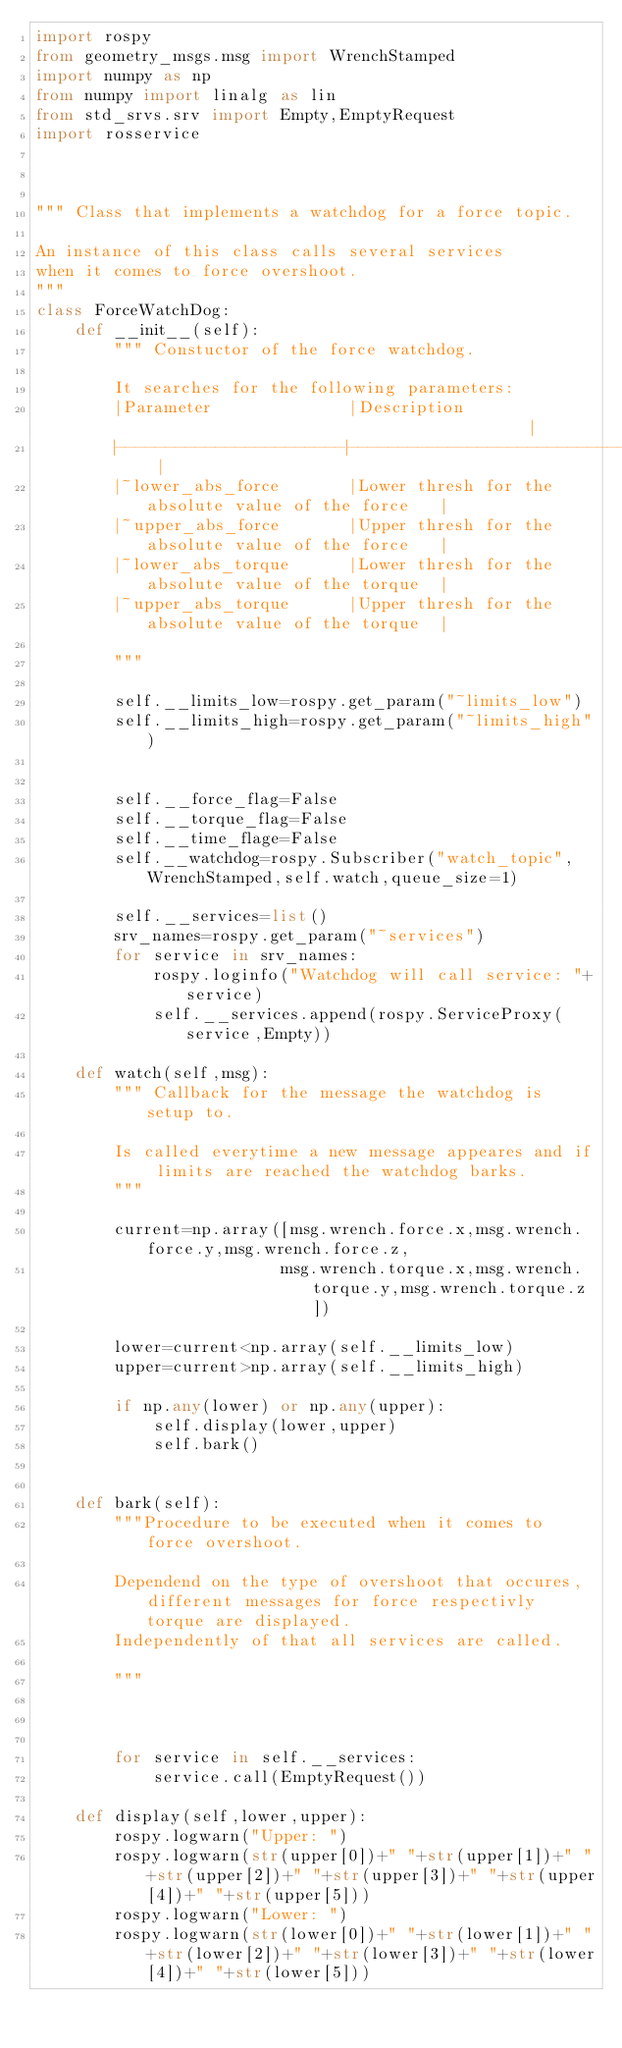<code> <loc_0><loc_0><loc_500><loc_500><_Python_>import rospy
from geometry_msgs.msg import WrenchStamped
import numpy as np
from numpy import linalg as lin
from std_srvs.srv import Empty,EmptyRequest
import rosservice



""" Class that implements a watchdog for a force topic.

An instance of this class calls several services 
when it comes to force overshoot.
"""
class ForceWatchDog:
    def __init__(self): 
        """ Constuctor of the force watchdog.
        
        It searches for the following parameters:
        |Parameter              |Description                                        |
        |-----------------------|-------------------------------------------------- |
        |~lower_abs_force       |Lower thresh for the absolute value of the force   |
        |~upper_abs_force       |Upper thresh for the absolute value of the force   |
        |~lower_abs_torque      |Lower thresh for the absolute value of the torque  |
        |~upper_abs_torque      |Upper thresh for the absolute value of the torque  |
        
        """     

        self.__limits_low=rospy.get_param("~limits_low")
        self.__limits_high=rospy.get_param("~limits_high")
       
       
        self.__force_flag=False
        self.__torque_flag=False
        self.__time_flage=False        
        self.__watchdog=rospy.Subscriber("watch_topic",WrenchStamped,self.watch,queue_size=1)
        
        self.__services=list()
        srv_names=rospy.get_param("~services")
        for service in srv_names:
            rospy.loginfo("Watchdog will call service: "+service)
            self.__services.append(rospy.ServiceProxy(service,Empty))

    def watch(self,msg):
        """ Callback for the message the watchdog is setup to.
        
        Is called everytime a new message appeares and if limits are reached the watchdog barks.
        """

        current=np.array([msg.wrench.force.x,msg.wrench.force.y,msg.wrench.force.z,
                         msg.wrench.torque.x,msg.wrench.torque.y,msg.wrench.torque.z])

        lower=current<np.array(self.__limits_low)
        upper=current>np.array(self.__limits_high)

        if np.any(lower) or np.any(upper):
            self.display(lower,upper)
            self.bark()
            

    def bark(self):
        """Procedure to be executed when it comes to force overshoot.

        Dependend on the type of overshoot that occures, different messages for force respectivly torque are displayed.
        Independently of that all services are called.

        """        
   
       
        
        for service in self.__services:
            service.call(EmptyRequest())
    
    def display(self,lower,upper):
        rospy.logwarn("Upper: ")
        rospy.logwarn(str(upper[0])+" "+str(upper[1])+" "+str(upper[2])+" "+str(upper[3])+" "+str(upper[4])+" "+str(upper[5]))
        rospy.logwarn("Lower: ")
        rospy.logwarn(str(lower[0])+" "+str(lower[1])+" "+str(lower[2])+" "+str(lower[3])+" "+str(lower[4])+" "+str(lower[5]))</code> 